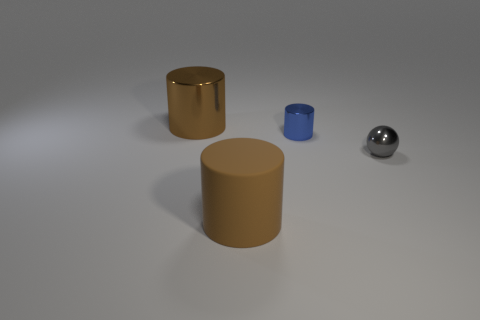Subtract all brown cylinders. How many cylinders are left? 1 Add 3 gray spheres. How many objects exist? 7 Subtract all cylinders. How many objects are left? 1 Add 1 tiny blue shiny objects. How many tiny blue shiny objects exist? 2 Subtract 1 gray balls. How many objects are left? 3 Subtract all big gray metallic spheres. Subtract all balls. How many objects are left? 3 Add 1 big cylinders. How many big cylinders are left? 3 